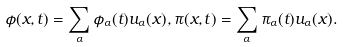Convert formula to latex. <formula><loc_0><loc_0><loc_500><loc_500>\phi ( { x } , t ) = \sum _ { \alpha } \phi _ { \alpha } ( t ) u _ { \alpha } ( { x } ) , \pi ( { x } , t ) = \sum _ { \alpha } \pi _ { \alpha } ( t ) u _ { \alpha } ( { x } ) .</formula> 